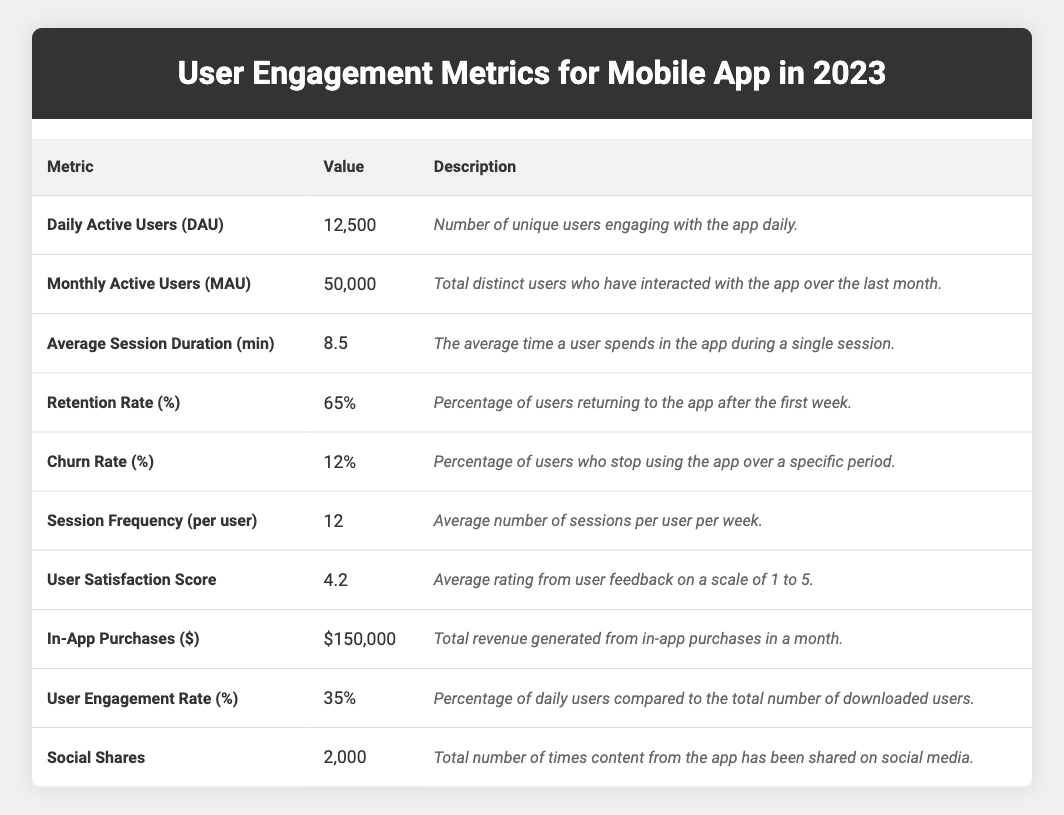What is the value for Daily Active Users (DAU)? The table indicates that the value for Daily Active Users (DAU) is 12,500 as listed under the corresponding metric.
Answer: 12,500 What is the User Satisfaction Score? According to the table, the User Satisfaction Score is 4.2, which represents the average rating given by users on a scale of 1 to 5.
Answer: 4.2 How many Monthly Active Users (MAU) are there? The table shows that the Monthly Active Users (MAU) is 50,000, which is the total number of unique users who interacted with the app over the last month.
Answer: 50,000 What percentage of users return after the first week? The table states that the Retention Rate is 65%, indicating the percentage of users who return to the app after the first week.
Answer: 65% What does the Churn Rate represent? The Churn Rate, which is listed as 12%, represents the percentage of users who stop using the app over a specific time period.
Answer: 12% What is the relationship between Daily Active Users (DAU) and User Engagement Rate? The User Engagement Rate is calculated as the percentage of daily users compared to total downloaded users. The DAU is 12,500, while the engagement rate is 35%, indicating that 35% of the total downloaded users engage with the app daily.
Answer: 35% relates to DAU being 12,500 How many total sessions are there per user per week? The table lists the Session Frequency per user as 12, meaning each user averages 12 sessions in a week.
Answer: 12 sessions What is the total revenue from In-App Purchases? According to the table, the total revenue from in-app purchases over the last month is $150,000.
Answer: $150,000 If the Average Session Duration is 8.5 minutes, how many total minutes are spent by DAU in a day? To find the total time spent, multiply the DAU of 12,500 by the Average Session Duration of 8.5 minutes: 12,500 * 8.5 = 106,250 minutes per day.
Answer: 106,250 minutes Is the average time spent in the app per session above or below 10 minutes? The Average Session Duration is 8.5 minutes, which is below 10 minutes. Therefore, the answer is yes, it is below 10 minutes.
Answer: Below What percentage of users engage with the app on a daily basis compared to total downloads? User Engagement Rate is given as 35%, which indicates this percentage of daily active users compared to the total downloads.
Answer: 35% Combining daily and monthly active users, what is the total engagement over the two periods? The total engagement metric over the periods would be 12,500 (DAU) multiplied by 30 days plus 50,000 (MAU). The calculation is (12,500 * 30) + 50,000 = 375,000. Therefore, the total engagement over both periods is 375,000.
Answer: 375,000 